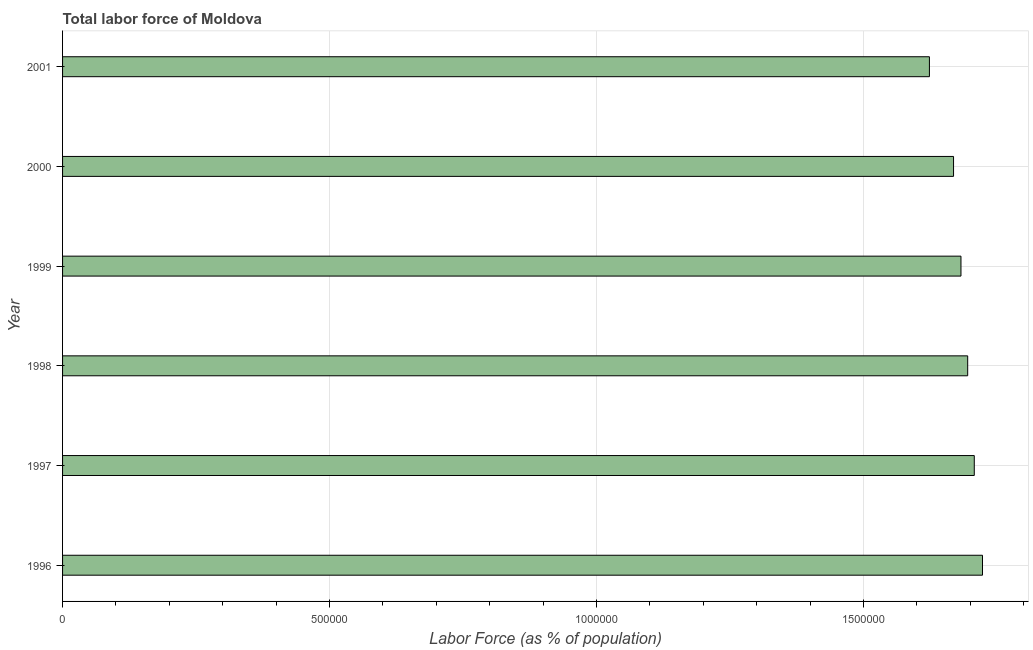Does the graph contain grids?
Offer a very short reply. Yes. What is the title of the graph?
Give a very brief answer. Total labor force of Moldova. What is the label or title of the X-axis?
Make the answer very short. Labor Force (as % of population). What is the label or title of the Y-axis?
Ensure brevity in your answer.  Year. What is the total labor force in 1998?
Keep it short and to the point. 1.70e+06. Across all years, what is the maximum total labor force?
Give a very brief answer. 1.72e+06. Across all years, what is the minimum total labor force?
Provide a short and direct response. 1.62e+06. What is the sum of the total labor force?
Provide a short and direct response. 1.01e+07. What is the difference between the total labor force in 1996 and 2000?
Ensure brevity in your answer.  5.42e+04. What is the average total labor force per year?
Make the answer very short. 1.68e+06. What is the median total labor force?
Your response must be concise. 1.69e+06. Do a majority of the years between 2000 and 2001 (inclusive) have total labor force greater than 900000 %?
Your answer should be very brief. Yes. What is the ratio of the total labor force in 1996 to that in 2000?
Your answer should be very brief. 1.03. What is the difference between the highest and the second highest total labor force?
Make the answer very short. 1.54e+04. Is the sum of the total labor force in 1996 and 2001 greater than the maximum total labor force across all years?
Give a very brief answer. Yes. What is the difference between the highest and the lowest total labor force?
Offer a very short reply. 9.94e+04. How many bars are there?
Ensure brevity in your answer.  6. Are the values on the major ticks of X-axis written in scientific E-notation?
Offer a very short reply. No. What is the Labor Force (as % of population) in 1996?
Your answer should be very brief. 1.72e+06. What is the Labor Force (as % of population) of 1997?
Provide a short and direct response. 1.71e+06. What is the Labor Force (as % of population) in 1998?
Make the answer very short. 1.70e+06. What is the Labor Force (as % of population) of 1999?
Provide a short and direct response. 1.68e+06. What is the Labor Force (as % of population) of 2000?
Ensure brevity in your answer.  1.67e+06. What is the Labor Force (as % of population) of 2001?
Keep it short and to the point. 1.62e+06. What is the difference between the Labor Force (as % of population) in 1996 and 1997?
Offer a terse response. 1.54e+04. What is the difference between the Labor Force (as % of population) in 1996 and 1998?
Your answer should be compact. 2.77e+04. What is the difference between the Labor Force (as % of population) in 1996 and 1999?
Provide a short and direct response. 4.03e+04. What is the difference between the Labor Force (as % of population) in 1996 and 2000?
Offer a terse response. 5.42e+04. What is the difference between the Labor Force (as % of population) in 1996 and 2001?
Your answer should be compact. 9.94e+04. What is the difference between the Labor Force (as % of population) in 1997 and 1998?
Your response must be concise. 1.23e+04. What is the difference between the Labor Force (as % of population) in 1997 and 1999?
Make the answer very short. 2.49e+04. What is the difference between the Labor Force (as % of population) in 1997 and 2000?
Provide a succinct answer. 3.88e+04. What is the difference between the Labor Force (as % of population) in 1997 and 2001?
Make the answer very short. 8.40e+04. What is the difference between the Labor Force (as % of population) in 1998 and 1999?
Your response must be concise. 1.26e+04. What is the difference between the Labor Force (as % of population) in 1998 and 2000?
Provide a succinct answer. 2.65e+04. What is the difference between the Labor Force (as % of population) in 1998 and 2001?
Your answer should be compact. 7.17e+04. What is the difference between the Labor Force (as % of population) in 1999 and 2000?
Make the answer very short. 1.39e+04. What is the difference between the Labor Force (as % of population) in 1999 and 2001?
Keep it short and to the point. 5.91e+04. What is the difference between the Labor Force (as % of population) in 2000 and 2001?
Your answer should be very brief. 4.52e+04. What is the ratio of the Labor Force (as % of population) in 1996 to that in 1998?
Offer a terse response. 1.02. What is the ratio of the Labor Force (as % of population) in 1996 to that in 2000?
Your answer should be very brief. 1.03. What is the ratio of the Labor Force (as % of population) in 1996 to that in 2001?
Keep it short and to the point. 1.06. What is the ratio of the Labor Force (as % of population) in 1997 to that in 1998?
Offer a very short reply. 1.01. What is the ratio of the Labor Force (as % of population) in 1997 to that in 1999?
Offer a very short reply. 1.01. What is the ratio of the Labor Force (as % of population) in 1997 to that in 2000?
Offer a terse response. 1.02. What is the ratio of the Labor Force (as % of population) in 1997 to that in 2001?
Make the answer very short. 1.05. What is the ratio of the Labor Force (as % of population) in 1998 to that in 2001?
Keep it short and to the point. 1.04. What is the ratio of the Labor Force (as % of population) in 1999 to that in 2001?
Your answer should be compact. 1.04. What is the ratio of the Labor Force (as % of population) in 2000 to that in 2001?
Your response must be concise. 1.03. 